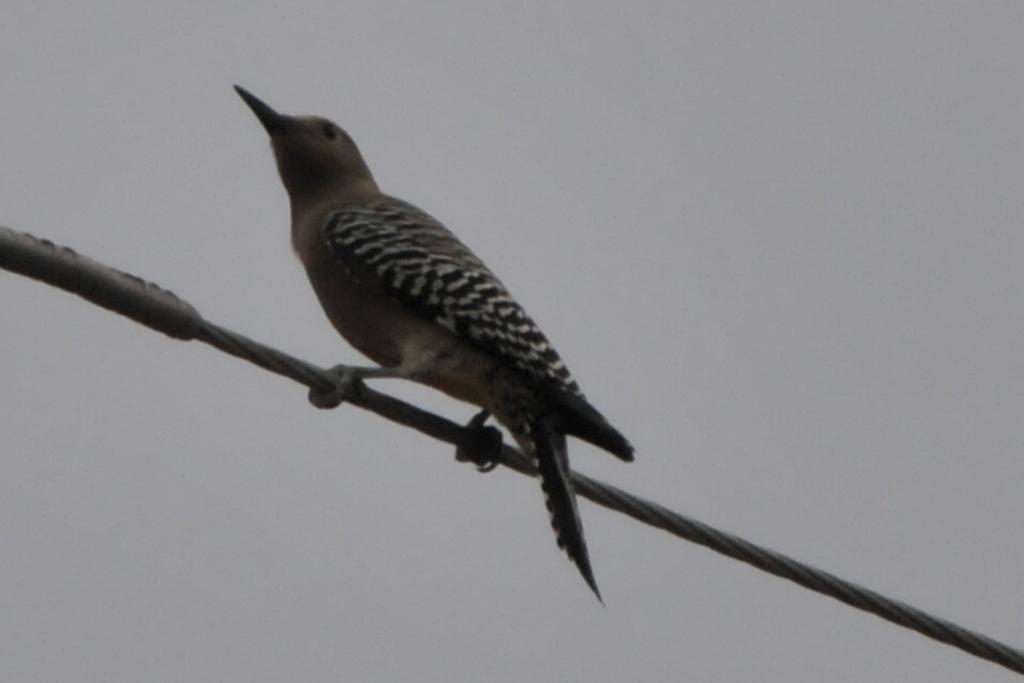What is the main subject of the picture? The main subject of the picture is a bird. Where is the bird located in the image? The bird is on a wire in the middle of the picture. What can be seen in the background of the image? There is sky visible in the background of the image. What type of neck can be seen on the deer in the image? There is no deer present in the image, so there is no neck to observe. 